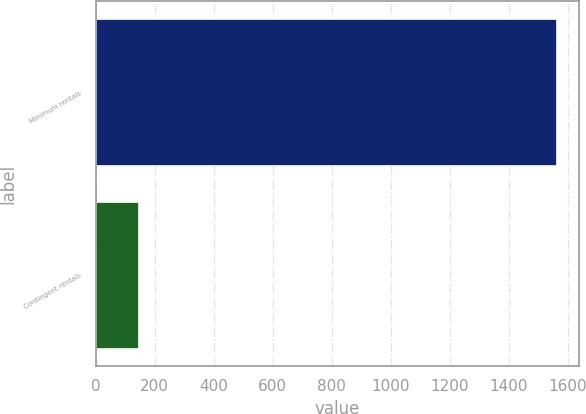Convert chart. <chart><loc_0><loc_0><loc_500><loc_500><bar_chart><fcel>Minimum rentals<fcel>Contingent rentals<nl><fcel>1560<fcel>143<nl></chart> 